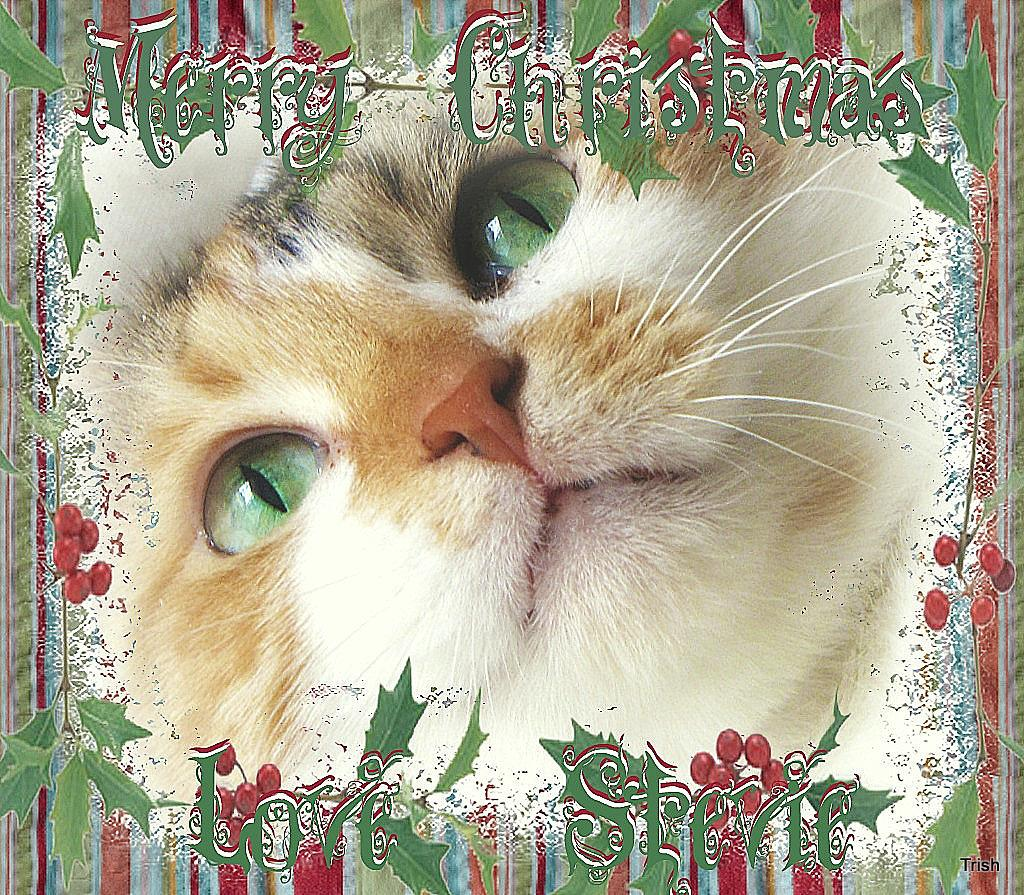What is the main subject of the image? The main subject of the image is a cat's face. Are there any words or letters in the image? Yes, there is some text in the image. What type of rake is being used by the cat in the image? There is no rake present in the image; it features a cat's face and some text. Can you tell me where the scissors are located in the image? There are no scissors present in the image. 